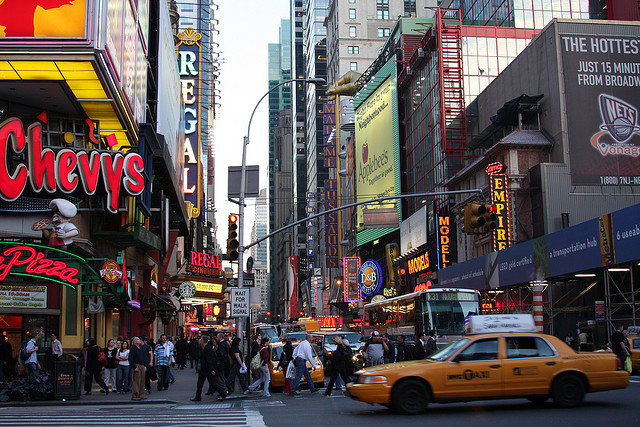What common drugstore is found nearby? Upon examining the image, there is a vibrant urban scene filled with various storefronts, and notably, there is a Walgreens drugstore located nearby amidst the bustling cityscape. 